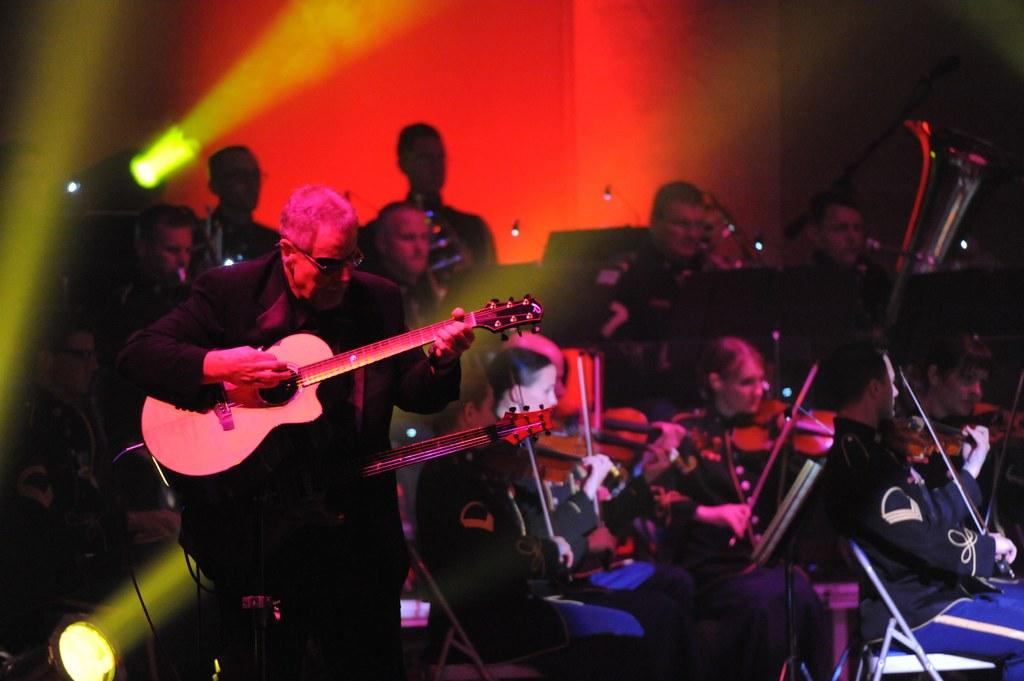What is happening in the image? There is a group of people in the image, and they are playing musical instruments. Where are the people playing their instruments? The people are on a stage. What type of cart is being used by the expert in the image? There is no cart or expert present in the image; it features a group of people playing musical instruments on a stage. 